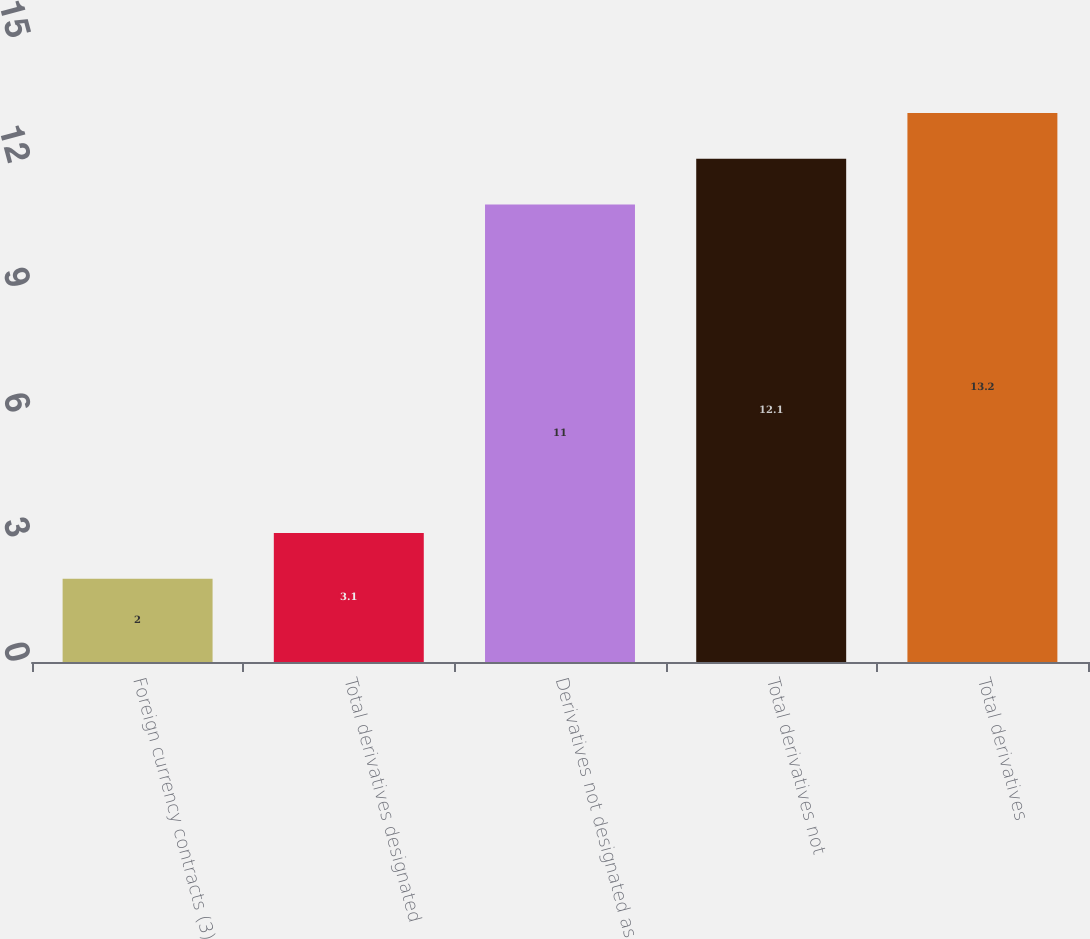Convert chart to OTSL. <chart><loc_0><loc_0><loc_500><loc_500><bar_chart><fcel>Foreign currency contracts (3)<fcel>Total derivatives designated<fcel>Derivatives not designated as<fcel>Total derivatives not<fcel>Total derivatives<nl><fcel>2<fcel>3.1<fcel>11<fcel>12.1<fcel>13.2<nl></chart> 